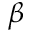<formula> <loc_0><loc_0><loc_500><loc_500>\beta</formula> 